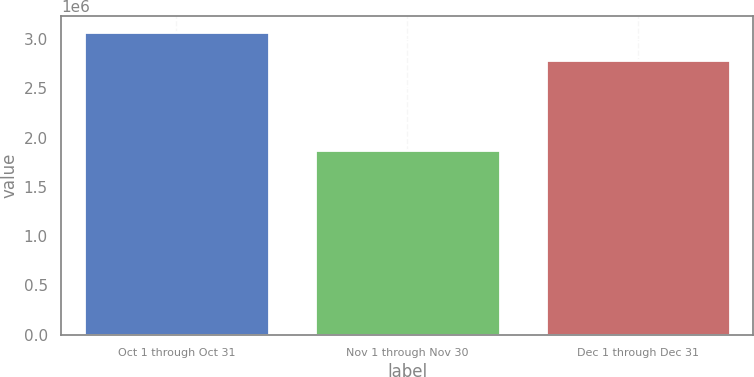Convert chart. <chart><loc_0><loc_0><loc_500><loc_500><bar_chart><fcel>Oct 1 through Oct 31<fcel>Nov 1 through Nov 30<fcel>Dec 1 through Dec 31<nl><fcel>3.075e+06<fcel>1.875e+06<fcel>2.7864e+06<nl></chart> 